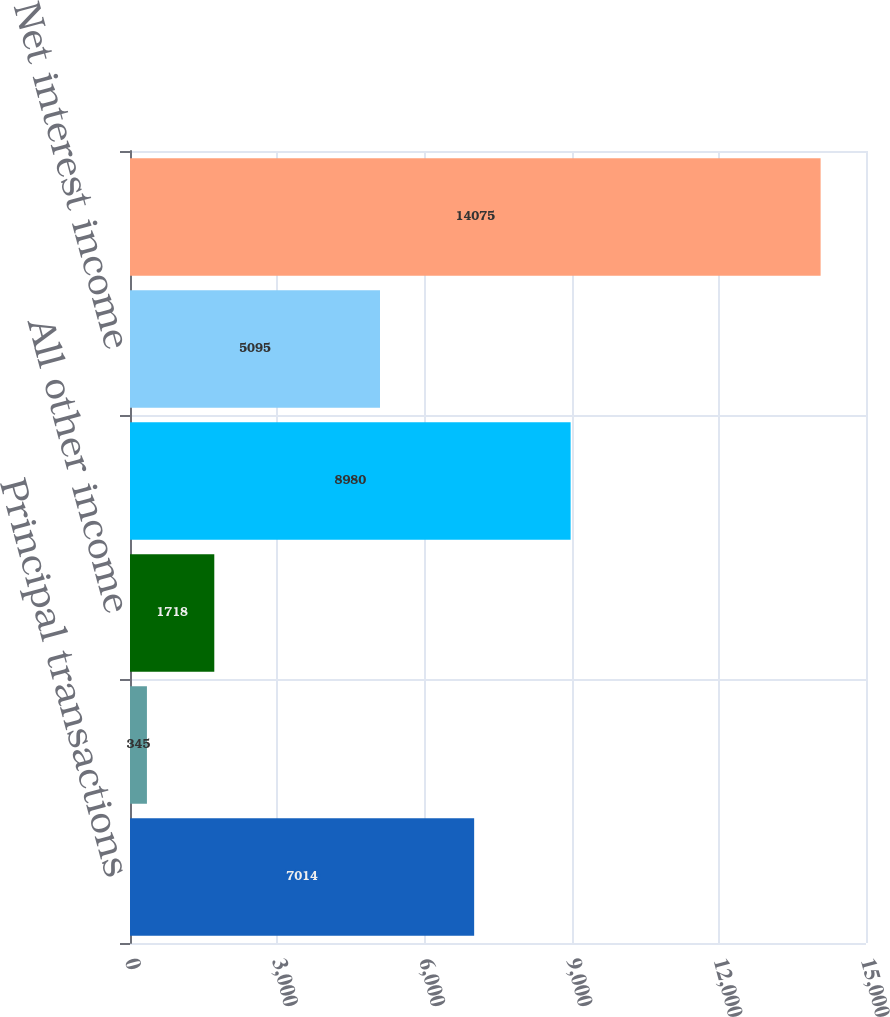<chart> <loc_0><loc_0><loc_500><loc_500><bar_chart><fcel>Principal transactions<fcel>Asset management<fcel>All other income<fcel>Noninterest revenue<fcel>Net interest income<fcel>Total net revenue<nl><fcel>7014<fcel>345<fcel>1718<fcel>8980<fcel>5095<fcel>14075<nl></chart> 